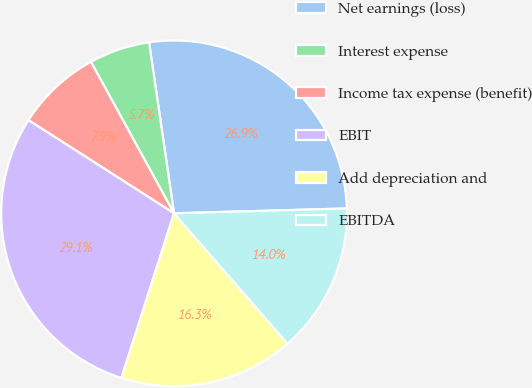Convert chart to OTSL. <chart><loc_0><loc_0><loc_500><loc_500><pie_chart><fcel>Net earnings (loss)<fcel>Interest expense<fcel>Income tax expense (benefit)<fcel>EBIT<fcel>Add depreciation and<fcel>EBITDA<nl><fcel>26.86%<fcel>5.68%<fcel>7.95%<fcel>29.14%<fcel>16.32%<fcel>14.05%<nl></chart> 